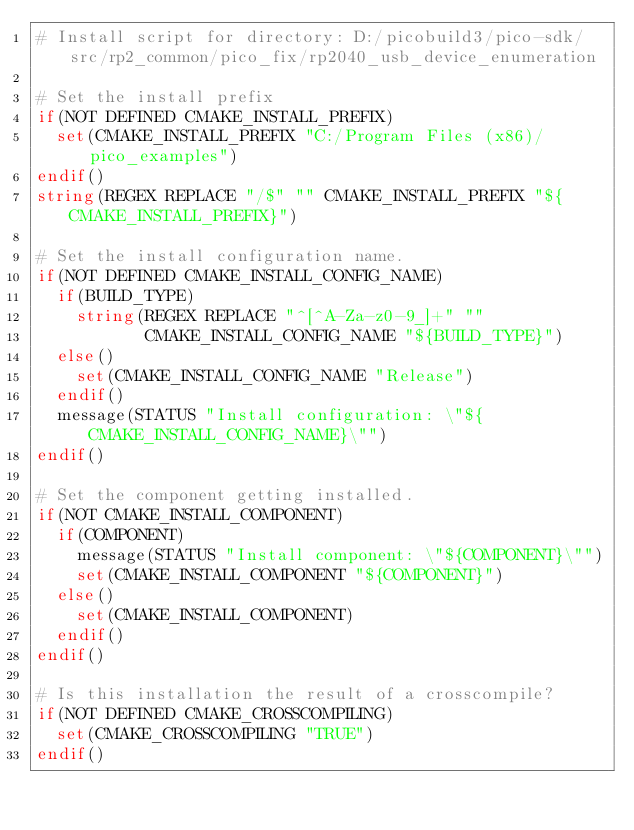<code> <loc_0><loc_0><loc_500><loc_500><_CMake_># Install script for directory: D:/picobuild3/pico-sdk/src/rp2_common/pico_fix/rp2040_usb_device_enumeration

# Set the install prefix
if(NOT DEFINED CMAKE_INSTALL_PREFIX)
  set(CMAKE_INSTALL_PREFIX "C:/Program Files (x86)/pico_examples")
endif()
string(REGEX REPLACE "/$" "" CMAKE_INSTALL_PREFIX "${CMAKE_INSTALL_PREFIX}")

# Set the install configuration name.
if(NOT DEFINED CMAKE_INSTALL_CONFIG_NAME)
  if(BUILD_TYPE)
    string(REGEX REPLACE "^[^A-Za-z0-9_]+" ""
           CMAKE_INSTALL_CONFIG_NAME "${BUILD_TYPE}")
  else()
    set(CMAKE_INSTALL_CONFIG_NAME "Release")
  endif()
  message(STATUS "Install configuration: \"${CMAKE_INSTALL_CONFIG_NAME}\"")
endif()

# Set the component getting installed.
if(NOT CMAKE_INSTALL_COMPONENT)
  if(COMPONENT)
    message(STATUS "Install component: \"${COMPONENT}\"")
    set(CMAKE_INSTALL_COMPONENT "${COMPONENT}")
  else()
    set(CMAKE_INSTALL_COMPONENT)
  endif()
endif()

# Is this installation the result of a crosscompile?
if(NOT DEFINED CMAKE_CROSSCOMPILING)
  set(CMAKE_CROSSCOMPILING "TRUE")
endif()

</code> 